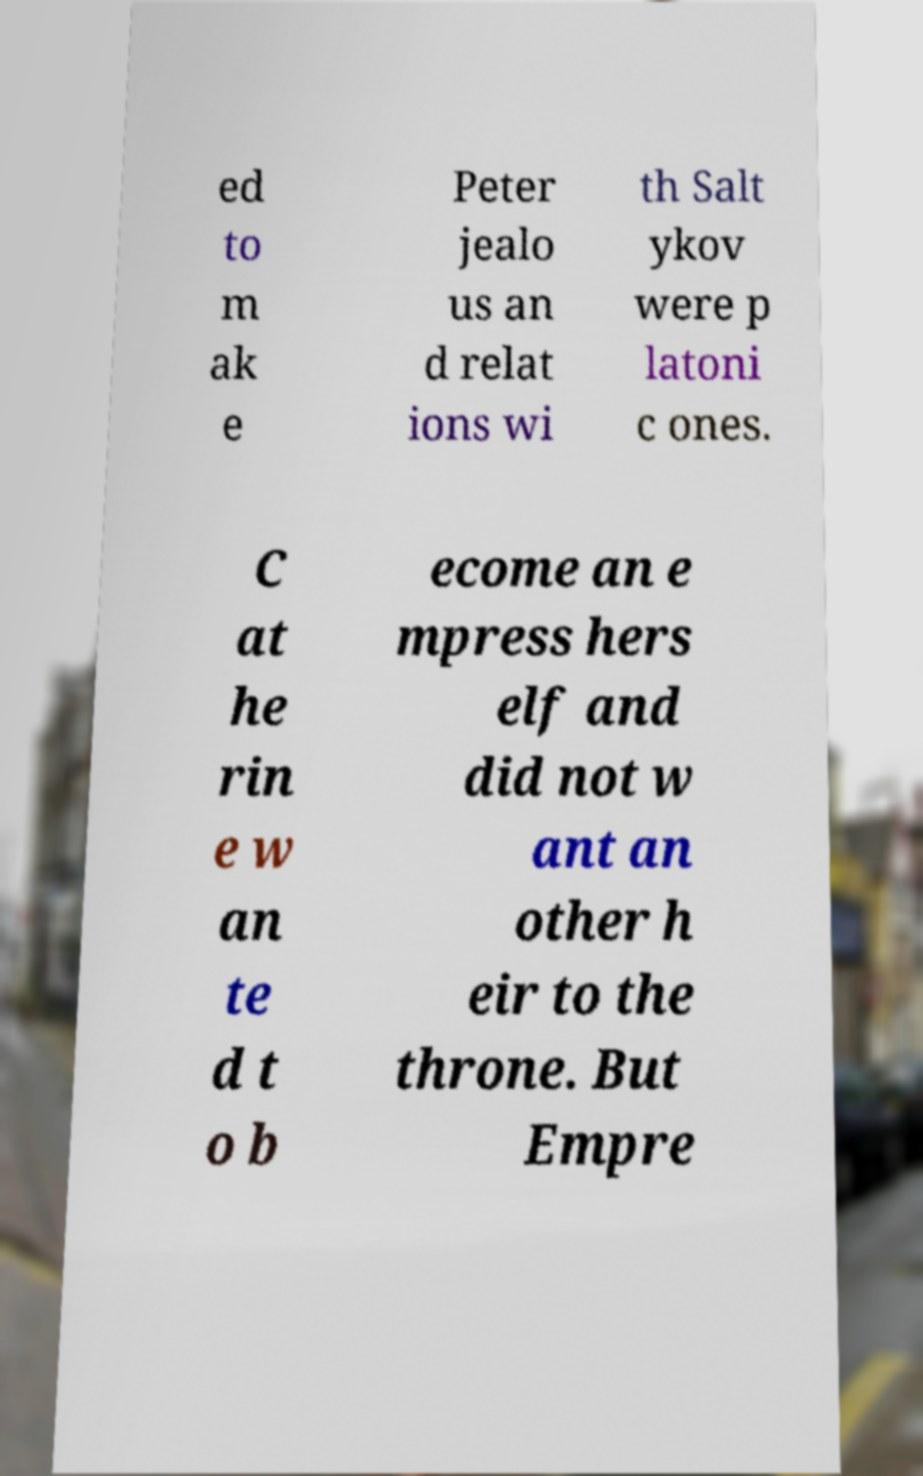Please read and relay the text visible in this image. What does it say? ed to m ak e Peter jealo us an d relat ions wi th Salt ykov were p latoni c ones. C at he rin e w an te d t o b ecome an e mpress hers elf and did not w ant an other h eir to the throne. But Empre 